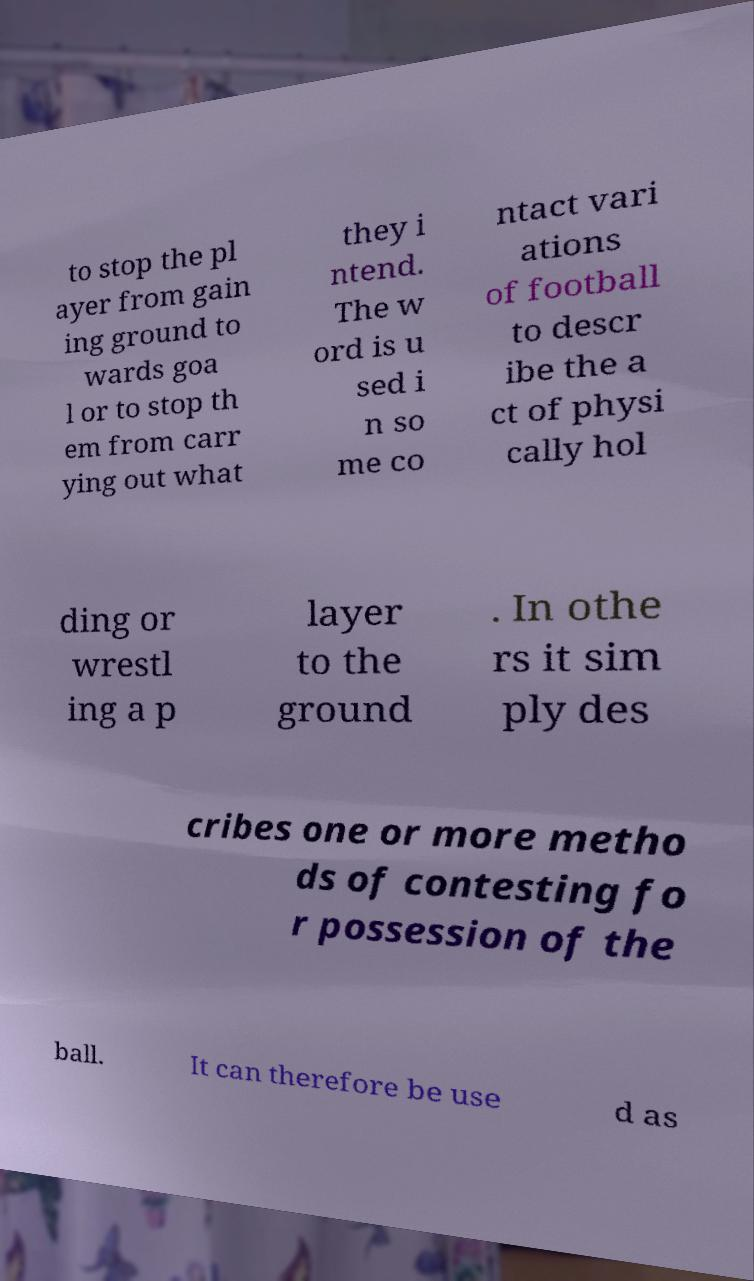Please read and relay the text visible in this image. What does it say? to stop the pl ayer from gain ing ground to wards goa l or to stop th em from carr ying out what they i ntend. The w ord is u sed i n so me co ntact vari ations of football to descr ibe the a ct of physi cally hol ding or wrestl ing a p layer to the ground . In othe rs it sim ply des cribes one or more metho ds of contesting fo r possession of the ball. It can therefore be use d as 